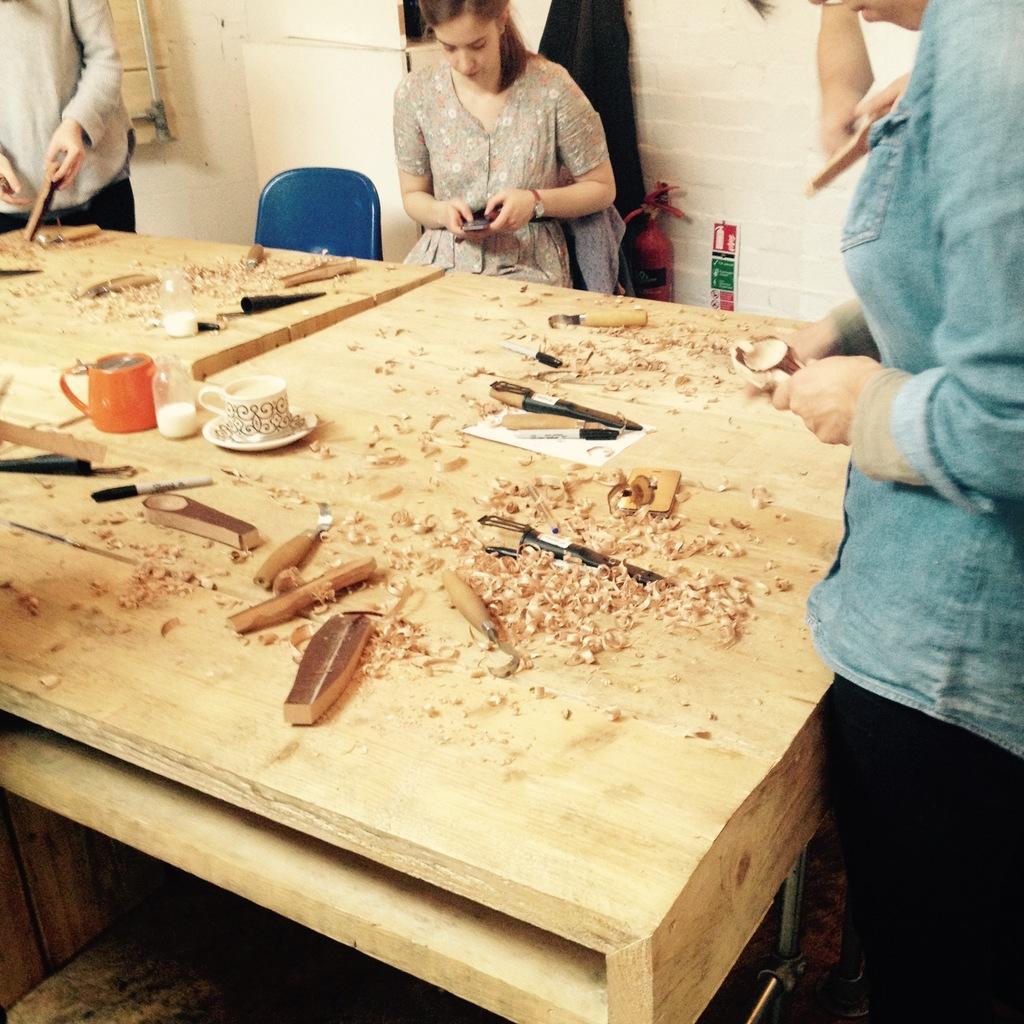In one or two sentences, can you explain what this image depicts? In this image we can see three persons. The woman is sitting on the chair. In front of the woman there is a wooden table. On table there is a cup,saucer,knife and a wood pieces. At the background there is a wall and a emergency cylinder. 